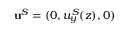Convert formula to latex. <formula><loc_0><loc_0><loc_500><loc_500>u ^ { S } = ( 0 , u _ { y } ^ { S } ( z ) , 0 )</formula> 